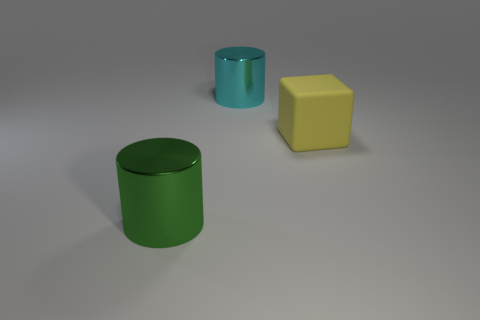Add 3 big red metallic cubes. How many objects exist? 6 Subtract all cyan cylinders. How many cylinders are left? 1 Subtract 1 cubes. How many cubes are left? 0 Add 2 rubber things. How many rubber things are left? 3 Add 2 blue objects. How many blue objects exist? 2 Subtract 0 brown cubes. How many objects are left? 3 Subtract all cylinders. How many objects are left? 1 Subtract all brown blocks. Subtract all cyan balls. How many blocks are left? 1 Subtract all blue balls. How many cyan cylinders are left? 1 Subtract all large cyan shiny balls. Subtract all green shiny cylinders. How many objects are left? 2 